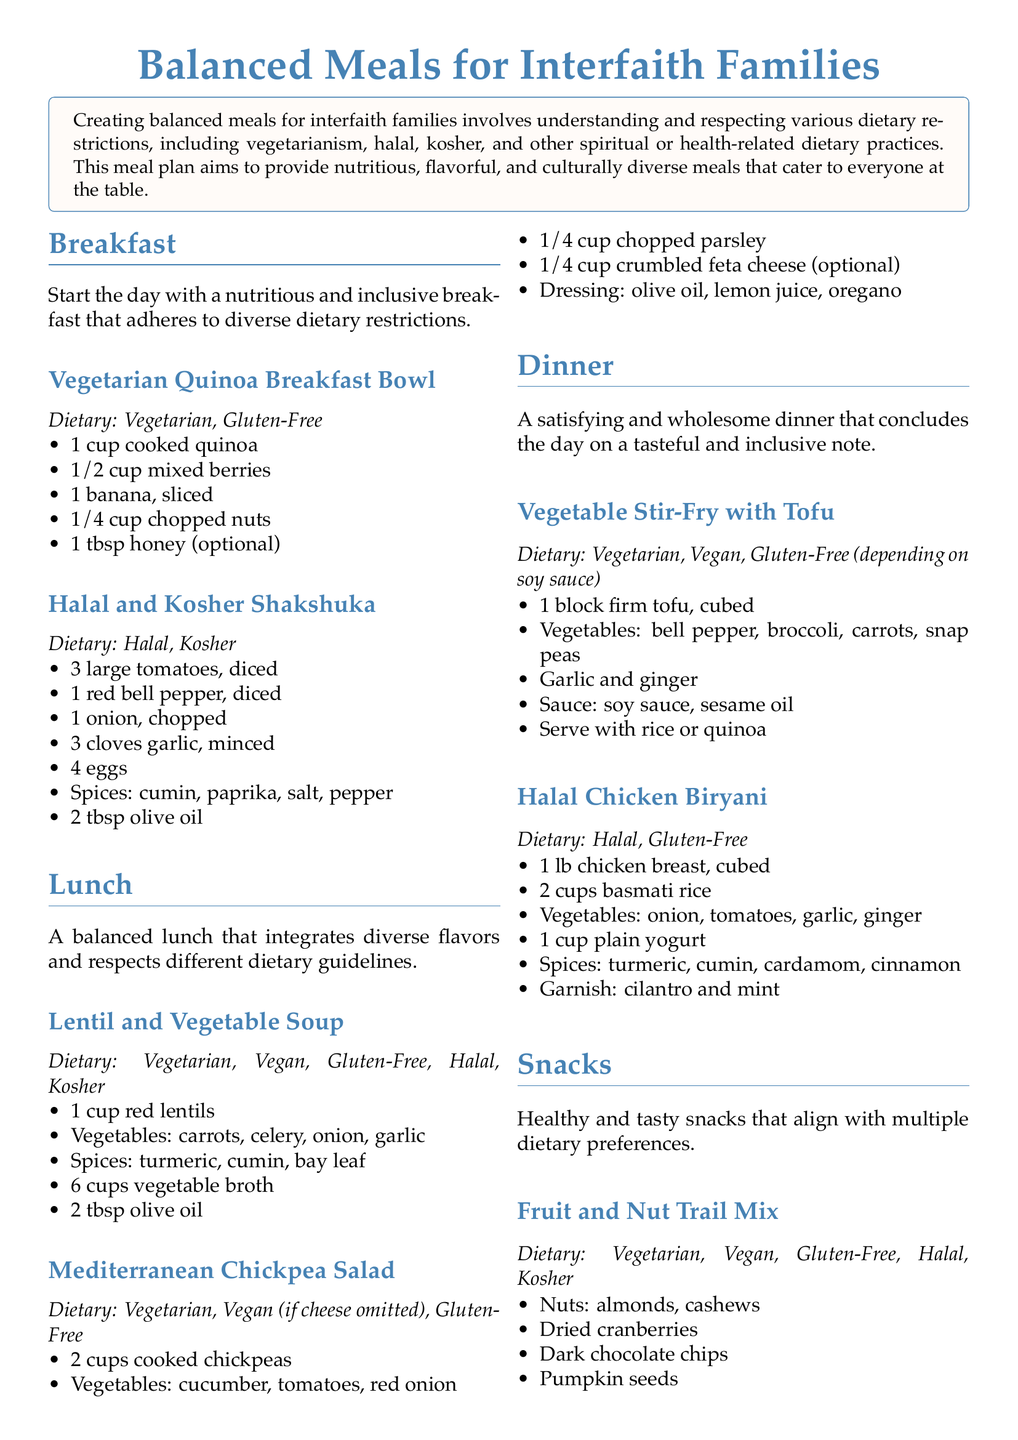What is the title of the meal plan? The title of the meal plan is prominently displayed at the top of the document.
Answer: Balanced Meals for Interfaith Families How many sections are included in the meal plan? The meal plan is organized into sections focused on different meal times such as Breakfast, Lunch, Dinner, and Snacks.
Answer: Four What dietary restrictions are mentioned for the Vegetarian Quinoa Breakfast Bowl? The dietary restrictions are specified under the meal description for the Vegetarian Quinoa Breakfast Bowl.
Answer: Vegetarian, Gluten-Free What is a key ingredient in the Halal and Kosher Shakshuka? The Halal and Kosher Shakshuka includes several primary ingredients as listed in the document.
Answer: Eggs Which dish is suitable for vegetarian, vegan, gluten-free, halal, and kosher diets? The document mentions a dish that adheres to all these dietary restrictions, providing its name in the lunch section.
Answer: Lentil and Vegetable Soup What kind of dressing is used in the Mediterranean Chickpea Salad? The dressing specifics are included as part of the ingredients list for the Mediterranean Chickpea Salad.
Answer: Olive oil, lemon juice, oregano How is the Vegetable Stir-Fry with Tofu served? The serving suggestion is provided as part of the meal description under the dinner section.
Answer: With rice or quinoa What type of snack can be enjoyed by everyone listed in the snack section? The document outlines multiple snacks, providing a specific example that aligns with multiple dietary preferences.
Answer: Vegetable Hummus Platter 